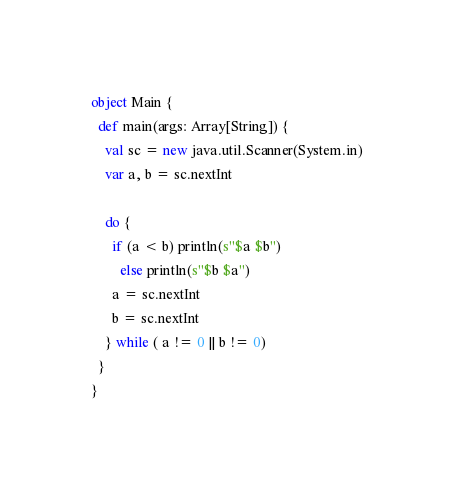Convert code to text. <code><loc_0><loc_0><loc_500><loc_500><_Scala_>object Main {
  def main(args: Array[String]) {
    val sc = new java.util.Scanner(System.in)
    var a, b = sc.nextInt

    do {
      if (a < b) println(s"$a $b")
        else println(s"$b $a")
      a = sc.nextInt
      b = sc.nextInt
    } while ( a != 0 || b != 0)
  }
}</code> 